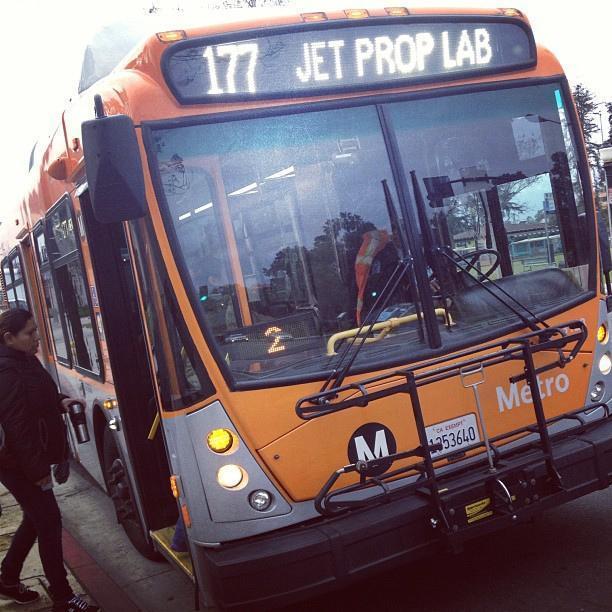How many people are there?
Give a very brief answer. 3. 